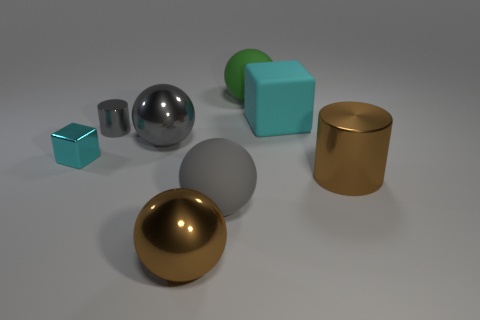Subtract all gray shiny spheres. How many spheres are left? 3 Add 1 large red metallic spheres. How many objects exist? 9 Subtract all green balls. How many balls are left? 3 Subtract all cyan blocks. How many brown balls are left? 1 Add 6 gray metallic cylinders. How many gray metallic cylinders exist? 7 Subtract 1 gray cylinders. How many objects are left? 7 Subtract all blocks. How many objects are left? 6 Subtract 2 spheres. How many spheres are left? 2 Subtract all green cylinders. Subtract all cyan blocks. How many cylinders are left? 2 Subtract all small gray metallic objects. Subtract all large brown shiny cylinders. How many objects are left? 6 